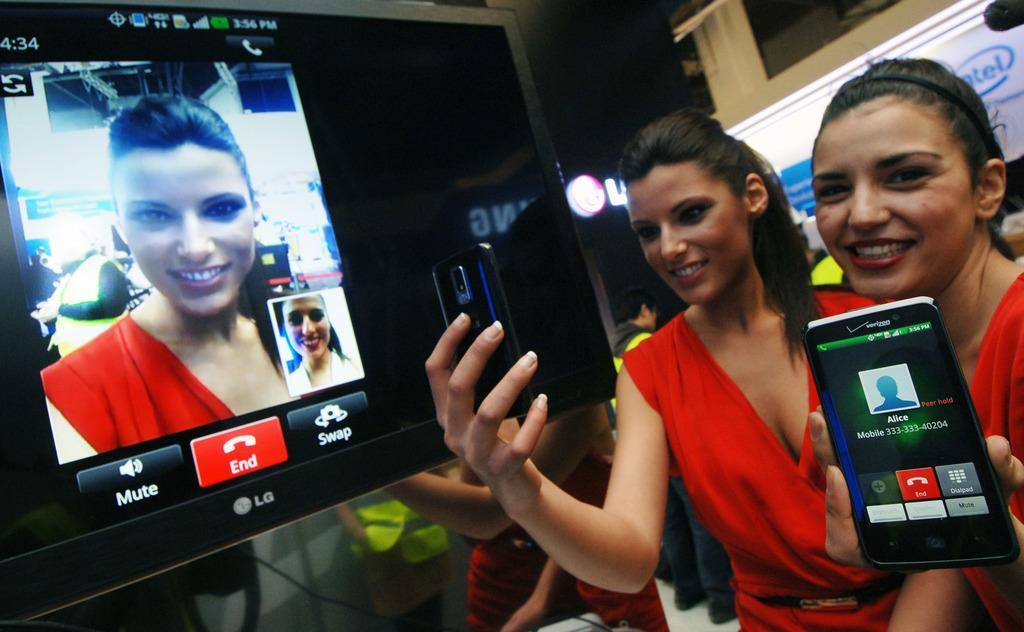In one or two sentences, can you explain what this image depicts? This picture shows two women standing and we see mobiles in their hands and we see a screen and a hoarding on their back 